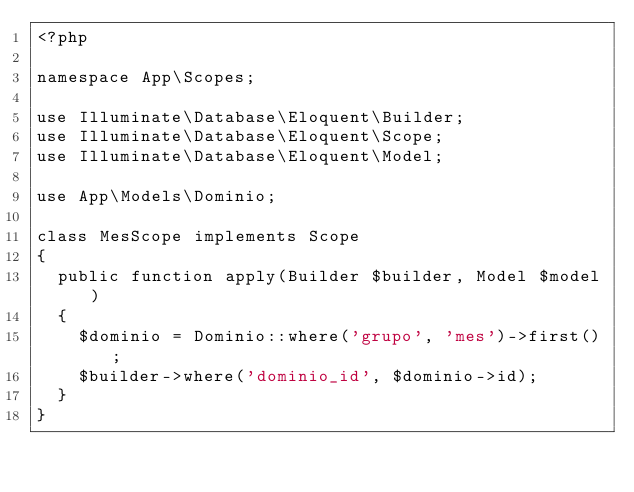<code> <loc_0><loc_0><loc_500><loc_500><_PHP_><?php

namespace App\Scopes;

use Illuminate\Database\Eloquent\Builder;
use Illuminate\Database\Eloquent\Scope;
use Illuminate\Database\Eloquent\Model;

use App\Models\Dominio;

class MesScope implements Scope
{
  public function apply(Builder $builder, Model $model)
  {
    $dominio = Dominio::where('grupo', 'mes')->first();
    $builder->where('dominio_id', $dominio->id);
  }
}

</code> 